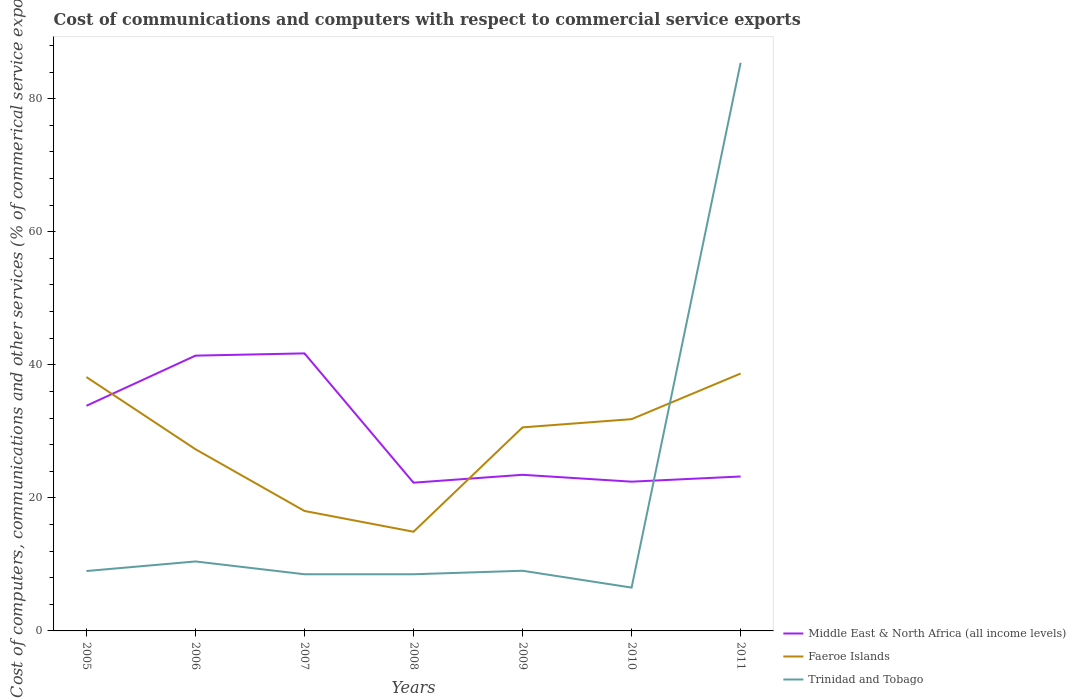How many different coloured lines are there?
Make the answer very short. 3. Does the line corresponding to Middle East & North Africa (all income levels) intersect with the line corresponding to Trinidad and Tobago?
Keep it short and to the point. Yes. Is the number of lines equal to the number of legend labels?
Your answer should be compact. Yes. Across all years, what is the maximum cost of communications and computers in Trinidad and Tobago?
Your answer should be compact. 6.51. What is the total cost of communications and computers in Trinidad and Tobago in the graph?
Your answer should be compact. 0.49. What is the difference between the highest and the second highest cost of communications and computers in Faeroe Islands?
Offer a terse response. 23.78. What is the difference between the highest and the lowest cost of communications and computers in Trinidad and Tobago?
Keep it short and to the point. 1. How many years are there in the graph?
Provide a short and direct response. 7. Are the values on the major ticks of Y-axis written in scientific E-notation?
Provide a succinct answer. No. Does the graph contain grids?
Offer a very short reply. No. How are the legend labels stacked?
Keep it short and to the point. Vertical. What is the title of the graph?
Offer a very short reply. Cost of communications and computers with respect to commercial service exports. What is the label or title of the X-axis?
Ensure brevity in your answer.  Years. What is the label or title of the Y-axis?
Offer a terse response. Cost of computers, communications and other services (% of commerical service exports). What is the Cost of computers, communications and other services (% of commerical service exports) of Middle East & North Africa (all income levels) in 2005?
Offer a terse response. 33.84. What is the Cost of computers, communications and other services (% of commerical service exports) in Faeroe Islands in 2005?
Give a very brief answer. 38.16. What is the Cost of computers, communications and other services (% of commerical service exports) of Trinidad and Tobago in 2005?
Your answer should be very brief. 9. What is the Cost of computers, communications and other services (% of commerical service exports) in Middle East & North Africa (all income levels) in 2006?
Give a very brief answer. 41.38. What is the Cost of computers, communications and other services (% of commerical service exports) of Faeroe Islands in 2006?
Ensure brevity in your answer.  27.32. What is the Cost of computers, communications and other services (% of commerical service exports) of Trinidad and Tobago in 2006?
Offer a terse response. 10.44. What is the Cost of computers, communications and other services (% of commerical service exports) of Middle East & North Africa (all income levels) in 2007?
Ensure brevity in your answer.  41.72. What is the Cost of computers, communications and other services (% of commerical service exports) of Faeroe Islands in 2007?
Your answer should be very brief. 18.03. What is the Cost of computers, communications and other services (% of commerical service exports) in Trinidad and Tobago in 2007?
Provide a succinct answer. 8.52. What is the Cost of computers, communications and other services (% of commerical service exports) of Middle East & North Africa (all income levels) in 2008?
Provide a succinct answer. 22.28. What is the Cost of computers, communications and other services (% of commerical service exports) in Faeroe Islands in 2008?
Your answer should be compact. 14.91. What is the Cost of computers, communications and other services (% of commerical service exports) in Trinidad and Tobago in 2008?
Offer a very short reply. 8.52. What is the Cost of computers, communications and other services (% of commerical service exports) in Middle East & North Africa (all income levels) in 2009?
Provide a short and direct response. 23.47. What is the Cost of computers, communications and other services (% of commerical service exports) of Faeroe Islands in 2009?
Make the answer very short. 30.6. What is the Cost of computers, communications and other services (% of commerical service exports) of Trinidad and Tobago in 2009?
Your response must be concise. 9.05. What is the Cost of computers, communications and other services (% of commerical service exports) of Middle East & North Africa (all income levels) in 2010?
Make the answer very short. 22.44. What is the Cost of computers, communications and other services (% of commerical service exports) in Faeroe Islands in 2010?
Your response must be concise. 31.83. What is the Cost of computers, communications and other services (% of commerical service exports) of Trinidad and Tobago in 2010?
Give a very brief answer. 6.51. What is the Cost of computers, communications and other services (% of commerical service exports) of Middle East & North Africa (all income levels) in 2011?
Your answer should be compact. 23.21. What is the Cost of computers, communications and other services (% of commerical service exports) of Faeroe Islands in 2011?
Ensure brevity in your answer.  38.69. What is the Cost of computers, communications and other services (% of commerical service exports) of Trinidad and Tobago in 2011?
Your answer should be compact. 85.4. Across all years, what is the maximum Cost of computers, communications and other services (% of commerical service exports) in Middle East & North Africa (all income levels)?
Give a very brief answer. 41.72. Across all years, what is the maximum Cost of computers, communications and other services (% of commerical service exports) of Faeroe Islands?
Offer a terse response. 38.69. Across all years, what is the maximum Cost of computers, communications and other services (% of commerical service exports) of Trinidad and Tobago?
Give a very brief answer. 85.4. Across all years, what is the minimum Cost of computers, communications and other services (% of commerical service exports) in Middle East & North Africa (all income levels)?
Offer a terse response. 22.28. Across all years, what is the minimum Cost of computers, communications and other services (% of commerical service exports) of Faeroe Islands?
Offer a very short reply. 14.91. Across all years, what is the minimum Cost of computers, communications and other services (% of commerical service exports) in Trinidad and Tobago?
Your answer should be compact. 6.51. What is the total Cost of computers, communications and other services (% of commerical service exports) of Middle East & North Africa (all income levels) in the graph?
Give a very brief answer. 208.35. What is the total Cost of computers, communications and other services (% of commerical service exports) in Faeroe Islands in the graph?
Make the answer very short. 199.54. What is the total Cost of computers, communications and other services (% of commerical service exports) in Trinidad and Tobago in the graph?
Your answer should be very brief. 137.44. What is the difference between the Cost of computers, communications and other services (% of commerical service exports) in Middle East & North Africa (all income levels) in 2005 and that in 2006?
Ensure brevity in your answer.  -7.54. What is the difference between the Cost of computers, communications and other services (% of commerical service exports) of Faeroe Islands in 2005 and that in 2006?
Your answer should be compact. 10.85. What is the difference between the Cost of computers, communications and other services (% of commerical service exports) of Trinidad and Tobago in 2005 and that in 2006?
Your answer should be compact. -1.44. What is the difference between the Cost of computers, communications and other services (% of commerical service exports) in Middle East & North Africa (all income levels) in 2005 and that in 2007?
Offer a terse response. -7.88. What is the difference between the Cost of computers, communications and other services (% of commerical service exports) of Faeroe Islands in 2005 and that in 2007?
Make the answer very short. 20.13. What is the difference between the Cost of computers, communications and other services (% of commerical service exports) in Trinidad and Tobago in 2005 and that in 2007?
Provide a short and direct response. 0.49. What is the difference between the Cost of computers, communications and other services (% of commerical service exports) in Middle East & North Africa (all income levels) in 2005 and that in 2008?
Keep it short and to the point. 11.56. What is the difference between the Cost of computers, communications and other services (% of commerical service exports) of Faeroe Islands in 2005 and that in 2008?
Make the answer very short. 23.25. What is the difference between the Cost of computers, communications and other services (% of commerical service exports) of Trinidad and Tobago in 2005 and that in 2008?
Keep it short and to the point. 0.49. What is the difference between the Cost of computers, communications and other services (% of commerical service exports) in Middle East & North Africa (all income levels) in 2005 and that in 2009?
Make the answer very short. 10.37. What is the difference between the Cost of computers, communications and other services (% of commerical service exports) in Faeroe Islands in 2005 and that in 2009?
Offer a very short reply. 7.56. What is the difference between the Cost of computers, communications and other services (% of commerical service exports) of Trinidad and Tobago in 2005 and that in 2009?
Keep it short and to the point. -0.04. What is the difference between the Cost of computers, communications and other services (% of commerical service exports) in Middle East & North Africa (all income levels) in 2005 and that in 2010?
Your response must be concise. 11.41. What is the difference between the Cost of computers, communications and other services (% of commerical service exports) in Faeroe Islands in 2005 and that in 2010?
Give a very brief answer. 6.33. What is the difference between the Cost of computers, communications and other services (% of commerical service exports) of Trinidad and Tobago in 2005 and that in 2010?
Your response must be concise. 2.49. What is the difference between the Cost of computers, communications and other services (% of commerical service exports) in Middle East & North Africa (all income levels) in 2005 and that in 2011?
Your response must be concise. 10.63. What is the difference between the Cost of computers, communications and other services (% of commerical service exports) in Faeroe Islands in 2005 and that in 2011?
Your answer should be compact. -0.53. What is the difference between the Cost of computers, communications and other services (% of commerical service exports) of Trinidad and Tobago in 2005 and that in 2011?
Your answer should be very brief. -76.39. What is the difference between the Cost of computers, communications and other services (% of commerical service exports) of Middle East & North Africa (all income levels) in 2006 and that in 2007?
Make the answer very short. -0.34. What is the difference between the Cost of computers, communications and other services (% of commerical service exports) in Faeroe Islands in 2006 and that in 2007?
Make the answer very short. 9.28. What is the difference between the Cost of computers, communications and other services (% of commerical service exports) of Trinidad and Tobago in 2006 and that in 2007?
Keep it short and to the point. 1.93. What is the difference between the Cost of computers, communications and other services (% of commerical service exports) in Middle East & North Africa (all income levels) in 2006 and that in 2008?
Your answer should be very brief. 19.1. What is the difference between the Cost of computers, communications and other services (% of commerical service exports) in Faeroe Islands in 2006 and that in 2008?
Your response must be concise. 12.41. What is the difference between the Cost of computers, communications and other services (% of commerical service exports) in Trinidad and Tobago in 2006 and that in 2008?
Give a very brief answer. 1.93. What is the difference between the Cost of computers, communications and other services (% of commerical service exports) of Middle East & North Africa (all income levels) in 2006 and that in 2009?
Offer a very short reply. 17.91. What is the difference between the Cost of computers, communications and other services (% of commerical service exports) in Faeroe Islands in 2006 and that in 2009?
Offer a terse response. -3.28. What is the difference between the Cost of computers, communications and other services (% of commerical service exports) in Trinidad and Tobago in 2006 and that in 2009?
Offer a terse response. 1.4. What is the difference between the Cost of computers, communications and other services (% of commerical service exports) in Middle East & North Africa (all income levels) in 2006 and that in 2010?
Offer a very short reply. 18.94. What is the difference between the Cost of computers, communications and other services (% of commerical service exports) in Faeroe Islands in 2006 and that in 2010?
Your answer should be very brief. -4.52. What is the difference between the Cost of computers, communications and other services (% of commerical service exports) in Trinidad and Tobago in 2006 and that in 2010?
Your answer should be compact. 3.93. What is the difference between the Cost of computers, communications and other services (% of commerical service exports) in Middle East & North Africa (all income levels) in 2006 and that in 2011?
Make the answer very short. 18.17. What is the difference between the Cost of computers, communications and other services (% of commerical service exports) of Faeroe Islands in 2006 and that in 2011?
Your answer should be very brief. -11.38. What is the difference between the Cost of computers, communications and other services (% of commerical service exports) in Trinidad and Tobago in 2006 and that in 2011?
Provide a succinct answer. -74.96. What is the difference between the Cost of computers, communications and other services (% of commerical service exports) in Middle East & North Africa (all income levels) in 2007 and that in 2008?
Give a very brief answer. 19.44. What is the difference between the Cost of computers, communications and other services (% of commerical service exports) in Faeroe Islands in 2007 and that in 2008?
Keep it short and to the point. 3.12. What is the difference between the Cost of computers, communications and other services (% of commerical service exports) of Trinidad and Tobago in 2007 and that in 2008?
Provide a succinct answer. 0. What is the difference between the Cost of computers, communications and other services (% of commerical service exports) of Middle East & North Africa (all income levels) in 2007 and that in 2009?
Your answer should be compact. 18.25. What is the difference between the Cost of computers, communications and other services (% of commerical service exports) in Faeroe Islands in 2007 and that in 2009?
Ensure brevity in your answer.  -12.57. What is the difference between the Cost of computers, communications and other services (% of commerical service exports) in Trinidad and Tobago in 2007 and that in 2009?
Your answer should be compact. -0.53. What is the difference between the Cost of computers, communications and other services (% of commerical service exports) of Middle East & North Africa (all income levels) in 2007 and that in 2010?
Offer a terse response. 19.28. What is the difference between the Cost of computers, communications and other services (% of commerical service exports) in Faeroe Islands in 2007 and that in 2010?
Ensure brevity in your answer.  -13.8. What is the difference between the Cost of computers, communications and other services (% of commerical service exports) in Trinidad and Tobago in 2007 and that in 2010?
Provide a succinct answer. 2. What is the difference between the Cost of computers, communications and other services (% of commerical service exports) of Middle East & North Africa (all income levels) in 2007 and that in 2011?
Your response must be concise. 18.51. What is the difference between the Cost of computers, communications and other services (% of commerical service exports) in Faeroe Islands in 2007 and that in 2011?
Your answer should be compact. -20.66. What is the difference between the Cost of computers, communications and other services (% of commerical service exports) of Trinidad and Tobago in 2007 and that in 2011?
Provide a succinct answer. -76.88. What is the difference between the Cost of computers, communications and other services (% of commerical service exports) in Middle East & North Africa (all income levels) in 2008 and that in 2009?
Make the answer very short. -1.19. What is the difference between the Cost of computers, communications and other services (% of commerical service exports) of Faeroe Islands in 2008 and that in 2009?
Give a very brief answer. -15.69. What is the difference between the Cost of computers, communications and other services (% of commerical service exports) of Trinidad and Tobago in 2008 and that in 2009?
Your answer should be very brief. -0.53. What is the difference between the Cost of computers, communications and other services (% of commerical service exports) in Middle East & North Africa (all income levels) in 2008 and that in 2010?
Keep it short and to the point. -0.15. What is the difference between the Cost of computers, communications and other services (% of commerical service exports) in Faeroe Islands in 2008 and that in 2010?
Provide a short and direct response. -16.92. What is the difference between the Cost of computers, communications and other services (% of commerical service exports) of Trinidad and Tobago in 2008 and that in 2010?
Offer a terse response. 2. What is the difference between the Cost of computers, communications and other services (% of commerical service exports) of Middle East & North Africa (all income levels) in 2008 and that in 2011?
Make the answer very short. -0.93. What is the difference between the Cost of computers, communications and other services (% of commerical service exports) of Faeroe Islands in 2008 and that in 2011?
Provide a succinct answer. -23.78. What is the difference between the Cost of computers, communications and other services (% of commerical service exports) in Trinidad and Tobago in 2008 and that in 2011?
Ensure brevity in your answer.  -76.88. What is the difference between the Cost of computers, communications and other services (% of commerical service exports) in Faeroe Islands in 2009 and that in 2010?
Offer a terse response. -1.24. What is the difference between the Cost of computers, communications and other services (% of commerical service exports) of Trinidad and Tobago in 2009 and that in 2010?
Give a very brief answer. 2.53. What is the difference between the Cost of computers, communications and other services (% of commerical service exports) in Middle East & North Africa (all income levels) in 2009 and that in 2011?
Make the answer very short. 0.25. What is the difference between the Cost of computers, communications and other services (% of commerical service exports) in Faeroe Islands in 2009 and that in 2011?
Your response must be concise. -8.1. What is the difference between the Cost of computers, communications and other services (% of commerical service exports) of Trinidad and Tobago in 2009 and that in 2011?
Offer a very short reply. -76.35. What is the difference between the Cost of computers, communications and other services (% of commerical service exports) in Middle East & North Africa (all income levels) in 2010 and that in 2011?
Your response must be concise. -0.78. What is the difference between the Cost of computers, communications and other services (% of commerical service exports) of Faeroe Islands in 2010 and that in 2011?
Offer a very short reply. -6.86. What is the difference between the Cost of computers, communications and other services (% of commerical service exports) of Trinidad and Tobago in 2010 and that in 2011?
Your answer should be compact. -78.88. What is the difference between the Cost of computers, communications and other services (% of commerical service exports) in Middle East & North Africa (all income levels) in 2005 and the Cost of computers, communications and other services (% of commerical service exports) in Faeroe Islands in 2006?
Offer a very short reply. 6.53. What is the difference between the Cost of computers, communications and other services (% of commerical service exports) of Middle East & North Africa (all income levels) in 2005 and the Cost of computers, communications and other services (% of commerical service exports) of Trinidad and Tobago in 2006?
Your answer should be compact. 23.4. What is the difference between the Cost of computers, communications and other services (% of commerical service exports) in Faeroe Islands in 2005 and the Cost of computers, communications and other services (% of commerical service exports) in Trinidad and Tobago in 2006?
Provide a short and direct response. 27.72. What is the difference between the Cost of computers, communications and other services (% of commerical service exports) in Middle East & North Africa (all income levels) in 2005 and the Cost of computers, communications and other services (% of commerical service exports) in Faeroe Islands in 2007?
Your answer should be very brief. 15.81. What is the difference between the Cost of computers, communications and other services (% of commerical service exports) of Middle East & North Africa (all income levels) in 2005 and the Cost of computers, communications and other services (% of commerical service exports) of Trinidad and Tobago in 2007?
Offer a very short reply. 25.33. What is the difference between the Cost of computers, communications and other services (% of commerical service exports) in Faeroe Islands in 2005 and the Cost of computers, communications and other services (% of commerical service exports) in Trinidad and Tobago in 2007?
Provide a short and direct response. 29.64. What is the difference between the Cost of computers, communications and other services (% of commerical service exports) of Middle East & North Africa (all income levels) in 2005 and the Cost of computers, communications and other services (% of commerical service exports) of Faeroe Islands in 2008?
Give a very brief answer. 18.93. What is the difference between the Cost of computers, communications and other services (% of commerical service exports) of Middle East & North Africa (all income levels) in 2005 and the Cost of computers, communications and other services (% of commerical service exports) of Trinidad and Tobago in 2008?
Offer a very short reply. 25.33. What is the difference between the Cost of computers, communications and other services (% of commerical service exports) in Faeroe Islands in 2005 and the Cost of computers, communications and other services (% of commerical service exports) in Trinidad and Tobago in 2008?
Your answer should be compact. 29.65. What is the difference between the Cost of computers, communications and other services (% of commerical service exports) of Middle East & North Africa (all income levels) in 2005 and the Cost of computers, communications and other services (% of commerical service exports) of Faeroe Islands in 2009?
Provide a short and direct response. 3.25. What is the difference between the Cost of computers, communications and other services (% of commerical service exports) of Middle East & North Africa (all income levels) in 2005 and the Cost of computers, communications and other services (% of commerical service exports) of Trinidad and Tobago in 2009?
Provide a short and direct response. 24.8. What is the difference between the Cost of computers, communications and other services (% of commerical service exports) in Faeroe Islands in 2005 and the Cost of computers, communications and other services (% of commerical service exports) in Trinidad and Tobago in 2009?
Keep it short and to the point. 29.12. What is the difference between the Cost of computers, communications and other services (% of commerical service exports) in Middle East & North Africa (all income levels) in 2005 and the Cost of computers, communications and other services (% of commerical service exports) in Faeroe Islands in 2010?
Your answer should be very brief. 2.01. What is the difference between the Cost of computers, communications and other services (% of commerical service exports) in Middle East & North Africa (all income levels) in 2005 and the Cost of computers, communications and other services (% of commerical service exports) in Trinidad and Tobago in 2010?
Your response must be concise. 27.33. What is the difference between the Cost of computers, communications and other services (% of commerical service exports) in Faeroe Islands in 2005 and the Cost of computers, communications and other services (% of commerical service exports) in Trinidad and Tobago in 2010?
Offer a terse response. 31.65. What is the difference between the Cost of computers, communications and other services (% of commerical service exports) of Middle East & North Africa (all income levels) in 2005 and the Cost of computers, communications and other services (% of commerical service exports) of Faeroe Islands in 2011?
Your answer should be compact. -4.85. What is the difference between the Cost of computers, communications and other services (% of commerical service exports) of Middle East & North Africa (all income levels) in 2005 and the Cost of computers, communications and other services (% of commerical service exports) of Trinidad and Tobago in 2011?
Make the answer very short. -51.55. What is the difference between the Cost of computers, communications and other services (% of commerical service exports) in Faeroe Islands in 2005 and the Cost of computers, communications and other services (% of commerical service exports) in Trinidad and Tobago in 2011?
Ensure brevity in your answer.  -47.24. What is the difference between the Cost of computers, communications and other services (% of commerical service exports) of Middle East & North Africa (all income levels) in 2006 and the Cost of computers, communications and other services (% of commerical service exports) of Faeroe Islands in 2007?
Provide a succinct answer. 23.35. What is the difference between the Cost of computers, communications and other services (% of commerical service exports) in Middle East & North Africa (all income levels) in 2006 and the Cost of computers, communications and other services (% of commerical service exports) in Trinidad and Tobago in 2007?
Ensure brevity in your answer.  32.86. What is the difference between the Cost of computers, communications and other services (% of commerical service exports) in Faeroe Islands in 2006 and the Cost of computers, communications and other services (% of commerical service exports) in Trinidad and Tobago in 2007?
Make the answer very short. 18.8. What is the difference between the Cost of computers, communications and other services (% of commerical service exports) in Middle East & North Africa (all income levels) in 2006 and the Cost of computers, communications and other services (% of commerical service exports) in Faeroe Islands in 2008?
Provide a succinct answer. 26.47. What is the difference between the Cost of computers, communications and other services (% of commerical service exports) of Middle East & North Africa (all income levels) in 2006 and the Cost of computers, communications and other services (% of commerical service exports) of Trinidad and Tobago in 2008?
Your response must be concise. 32.87. What is the difference between the Cost of computers, communications and other services (% of commerical service exports) in Faeroe Islands in 2006 and the Cost of computers, communications and other services (% of commerical service exports) in Trinidad and Tobago in 2008?
Your response must be concise. 18.8. What is the difference between the Cost of computers, communications and other services (% of commerical service exports) in Middle East & North Africa (all income levels) in 2006 and the Cost of computers, communications and other services (% of commerical service exports) in Faeroe Islands in 2009?
Give a very brief answer. 10.78. What is the difference between the Cost of computers, communications and other services (% of commerical service exports) of Middle East & North Africa (all income levels) in 2006 and the Cost of computers, communications and other services (% of commerical service exports) of Trinidad and Tobago in 2009?
Give a very brief answer. 32.34. What is the difference between the Cost of computers, communications and other services (% of commerical service exports) of Faeroe Islands in 2006 and the Cost of computers, communications and other services (% of commerical service exports) of Trinidad and Tobago in 2009?
Make the answer very short. 18.27. What is the difference between the Cost of computers, communications and other services (% of commerical service exports) of Middle East & North Africa (all income levels) in 2006 and the Cost of computers, communications and other services (% of commerical service exports) of Faeroe Islands in 2010?
Your response must be concise. 9.55. What is the difference between the Cost of computers, communications and other services (% of commerical service exports) of Middle East & North Africa (all income levels) in 2006 and the Cost of computers, communications and other services (% of commerical service exports) of Trinidad and Tobago in 2010?
Offer a terse response. 34.87. What is the difference between the Cost of computers, communications and other services (% of commerical service exports) of Faeroe Islands in 2006 and the Cost of computers, communications and other services (% of commerical service exports) of Trinidad and Tobago in 2010?
Offer a terse response. 20.8. What is the difference between the Cost of computers, communications and other services (% of commerical service exports) of Middle East & North Africa (all income levels) in 2006 and the Cost of computers, communications and other services (% of commerical service exports) of Faeroe Islands in 2011?
Your answer should be very brief. 2.69. What is the difference between the Cost of computers, communications and other services (% of commerical service exports) of Middle East & North Africa (all income levels) in 2006 and the Cost of computers, communications and other services (% of commerical service exports) of Trinidad and Tobago in 2011?
Keep it short and to the point. -44.02. What is the difference between the Cost of computers, communications and other services (% of commerical service exports) of Faeroe Islands in 2006 and the Cost of computers, communications and other services (% of commerical service exports) of Trinidad and Tobago in 2011?
Your answer should be compact. -58.08. What is the difference between the Cost of computers, communications and other services (% of commerical service exports) in Middle East & North Africa (all income levels) in 2007 and the Cost of computers, communications and other services (% of commerical service exports) in Faeroe Islands in 2008?
Offer a terse response. 26.81. What is the difference between the Cost of computers, communications and other services (% of commerical service exports) in Middle East & North Africa (all income levels) in 2007 and the Cost of computers, communications and other services (% of commerical service exports) in Trinidad and Tobago in 2008?
Make the answer very short. 33.2. What is the difference between the Cost of computers, communications and other services (% of commerical service exports) of Faeroe Islands in 2007 and the Cost of computers, communications and other services (% of commerical service exports) of Trinidad and Tobago in 2008?
Your response must be concise. 9.51. What is the difference between the Cost of computers, communications and other services (% of commerical service exports) of Middle East & North Africa (all income levels) in 2007 and the Cost of computers, communications and other services (% of commerical service exports) of Faeroe Islands in 2009?
Provide a succinct answer. 11.12. What is the difference between the Cost of computers, communications and other services (% of commerical service exports) of Middle East & North Africa (all income levels) in 2007 and the Cost of computers, communications and other services (% of commerical service exports) of Trinidad and Tobago in 2009?
Your response must be concise. 32.67. What is the difference between the Cost of computers, communications and other services (% of commerical service exports) of Faeroe Islands in 2007 and the Cost of computers, communications and other services (% of commerical service exports) of Trinidad and Tobago in 2009?
Offer a terse response. 8.99. What is the difference between the Cost of computers, communications and other services (% of commerical service exports) in Middle East & North Africa (all income levels) in 2007 and the Cost of computers, communications and other services (% of commerical service exports) in Faeroe Islands in 2010?
Provide a succinct answer. 9.89. What is the difference between the Cost of computers, communications and other services (% of commerical service exports) of Middle East & North Africa (all income levels) in 2007 and the Cost of computers, communications and other services (% of commerical service exports) of Trinidad and Tobago in 2010?
Make the answer very short. 35.21. What is the difference between the Cost of computers, communications and other services (% of commerical service exports) in Faeroe Islands in 2007 and the Cost of computers, communications and other services (% of commerical service exports) in Trinidad and Tobago in 2010?
Provide a succinct answer. 11.52. What is the difference between the Cost of computers, communications and other services (% of commerical service exports) in Middle East & North Africa (all income levels) in 2007 and the Cost of computers, communications and other services (% of commerical service exports) in Faeroe Islands in 2011?
Offer a very short reply. 3.03. What is the difference between the Cost of computers, communications and other services (% of commerical service exports) of Middle East & North Africa (all income levels) in 2007 and the Cost of computers, communications and other services (% of commerical service exports) of Trinidad and Tobago in 2011?
Your response must be concise. -43.68. What is the difference between the Cost of computers, communications and other services (% of commerical service exports) in Faeroe Islands in 2007 and the Cost of computers, communications and other services (% of commerical service exports) in Trinidad and Tobago in 2011?
Provide a short and direct response. -67.37. What is the difference between the Cost of computers, communications and other services (% of commerical service exports) of Middle East & North Africa (all income levels) in 2008 and the Cost of computers, communications and other services (% of commerical service exports) of Faeroe Islands in 2009?
Ensure brevity in your answer.  -8.31. What is the difference between the Cost of computers, communications and other services (% of commerical service exports) of Middle East & North Africa (all income levels) in 2008 and the Cost of computers, communications and other services (% of commerical service exports) of Trinidad and Tobago in 2009?
Make the answer very short. 13.24. What is the difference between the Cost of computers, communications and other services (% of commerical service exports) of Faeroe Islands in 2008 and the Cost of computers, communications and other services (% of commerical service exports) of Trinidad and Tobago in 2009?
Provide a succinct answer. 5.86. What is the difference between the Cost of computers, communications and other services (% of commerical service exports) of Middle East & North Africa (all income levels) in 2008 and the Cost of computers, communications and other services (% of commerical service exports) of Faeroe Islands in 2010?
Keep it short and to the point. -9.55. What is the difference between the Cost of computers, communications and other services (% of commerical service exports) in Middle East & North Africa (all income levels) in 2008 and the Cost of computers, communications and other services (% of commerical service exports) in Trinidad and Tobago in 2010?
Give a very brief answer. 15.77. What is the difference between the Cost of computers, communications and other services (% of commerical service exports) of Faeroe Islands in 2008 and the Cost of computers, communications and other services (% of commerical service exports) of Trinidad and Tobago in 2010?
Provide a short and direct response. 8.4. What is the difference between the Cost of computers, communications and other services (% of commerical service exports) in Middle East & North Africa (all income levels) in 2008 and the Cost of computers, communications and other services (% of commerical service exports) in Faeroe Islands in 2011?
Provide a succinct answer. -16.41. What is the difference between the Cost of computers, communications and other services (% of commerical service exports) in Middle East & North Africa (all income levels) in 2008 and the Cost of computers, communications and other services (% of commerical service exports) in Trinidad and Tobago in 2011?
Ensure brevity in your answer.  -63.12. What is the difference between the Cost of computers, communications and other services (% of commerical service exports) of Faeroe Islands in 2008 and the Cost of computers, communications and other services (% of commerical service exports) of Trinidad and Tobago in 2011?
Keep it short and to the point. -70.49. What is the difference between the Cost of computers, communications and other services (% of commerical service exports) of Middle East & North Africa (all income levels) in 2009 and the Cost of computers, communications and other services (% of commerical service exports) of Faeroe Islands in 2010?
Ensure brevity in your answer.  -8.36. What is the difference between the Cost of computers, communications and other services (% of commerical service exports) in Middle East & North Africa (all income levels) in 2009 and the Cost of computers, communications and other services (% of commerical service exports) in Trinidad and Tobago in 2010?
Give a very brief answer. 16.95. What is the difference between the Cost of computers, communications and other services (% of commerical service exports) of Faeroe Islands in 2009 and the Cost of computers, communications and other services (% of commerical service exports) of Trinidad and Tobago in 2010?
Your response must be concise. 24.08. What is the difference between the Cost of computers, communications and other services (% of commerical service exports) of Middle East & North Africa (all income levels) in 2009 and the Cost of computers, communications and other services (% of commerical service exports) of Faeroe Islands in 2011?
Your answer should be compact. -15.22. What is the difference between the Cost of computers, communications and other services (% of commerical service exports) in Middle East & North Africa (all income levels) in 2009 and the Cost of computers, communications and other services (% of commerical service exports) in Trinidad and Tobago in 2011?
Offer a very short reply. -61.93. What is the difference between the Cost of computers, communications and other services (% of commerical service exports) in Faeroe Islands in 2009 and the Cost of computers, communications and other services (% of commerical service exports) in Trinidad and Tobago in 2011?
Make the answer very short. -54.8. What is the difference between the Cost of computers, communications and other services (% of commerical service exports) of Middle East & North Africa (all income levels) in 2010 and the Cost of computers, communications and other services (% of commerical service exports) of Faeroe Islands in 2011?
Provide a succinct answer. -16.26. What is the difference between the Cost of computers, communications and other services (% of commerical service exports) in Middle East & North Africa (all income levels) in 2010 and the Cost of computers, communications and other services (% of commerical service exports) in Trinidad and Tobago in 2011?
Offer a terse response. -62.96. What is the difference between the Cost of computers, communications and other services (% of commerical service exports) of Faeroe Islands in 2010 and the Cost of computers, communications and other services (% of commerical service exports) of Trinidad and Tobago in 2011?
Your answer should be compact. -53.57. What is the average Cost of computers, communications and other services (% of commerical service exports) in Middle East & North Africa (all income levels) per year?
Provide a short and direct response. 29.76. What is the average Cost of computers, communications and other services (% of commerical service exports) of Faeroe Islands per year?
Give a very brief answer. 28.51. What is the average Cost of computers, communications and other services (% of commerical service exports) of Trinidad and Tobago per year?
Keep it short and to the point. 19.63. In the year 2005, what is the difference between the Cost of computers, communications and other services (% of commerical service exports) of Middle East & North Africa (all income levels) and Cost of computers, communications and other services (% of commerical service exports) of Faeroe Islands?
Keep it short and to the point. -4.32. In the year 2005, what is the difference between the Cost of computers, communications and other services (% of commerical service exports) in Middle East & North Africa (all income levels) and Cost of computers, communications and other services (% of commerical service exports) in Trinidad and Tobago?
Make the answer very short. 24.84. In the year 2005, what is the difference between the Cost of computers, communications and other services (% of commerical service exports) in Faeroe Islands and Cost of computers, communications and other services (% of commerical service exports) in Trinidad and Tobago?
Ensure brevity in your answer.  29.16. In the year 2006, what is the difference between the Cost of computers, communications and other services (% of commerical service exports) of Middle East & North Africa (all income levels) and Cost of computers, communications and other services (% of commerical service exports) of Faeroe Islands?
Your answer should be very brief. 14.07. In the year 2006, what is the difference between the Cost of computers, communications and other services (% of commerical service exports) of Middle East & North Africa (all income levels) and Cost of computers, communications and other services (% of commerical service exports) of Trinidad and Tobago?
Your answer should be very brief. 30.94. In the year 2006, what is the difference between the Cost of computers, communications and other services (% of commerical service exports) of Faeroe Islands and Cost of computers, communications and other services (% of commerical service exports) of Trinidad and Tobago?
Provide a short and direct response. 16.87. In the year 2007, what is the difference between the Cost of computers, communications and other services (% of commerical service exports) in Middle East & North Africa (all income levels) and Cost of computers, communications and other services (% of commerical service exports) in Faeroe Islands?
Your answer should be very brief. 23.69. In the year 2007, what is the difference between the Cost of computers, communications and other services (% of commerical service exports) of Middle East & North Africa (all income levels) and Cost of computers, communications and other services (% of commerical service exports) of Trinidad and Tobago?
Give a very brief answer. 33.2. In the year 2007, what is the difference between the Cost of computers, communications and other services (% of commerical service exports) in Faeroe Islands and Cost of computers, communications and other services (% of commerical service exports) in Trinidad and Tobago?
Provide a short and direct response. 9.51. In the year 2008, what is the difference between the Cost of computers, communications and other services (% of commerical service exports) of Middle East & North Africa (all income levels) and Cost of computers, communications and other services (% of commerical service exports) of Faeroe Islands?
Offer a very short reply. 7.37. In the year 2008, what is the difference between the Cost of computers, communications and other services (% of commerical service exports) of Middle East & North Africa (all income levels) and Cost of computers, communications and other services (% of commerical service exports) of Trinidad and Tobago?
Provide a short and direct response. 13.77. In the year 2008, what is the difference between the Cost of computers, communications and other services (% of commerical service exports) of Faeroe Islands and Cost of computers, communications and other services (% of commerical service exports) of Trinidad and Tobago?
Provide a short and direct response. 6.39. In the year 2009, what is the difference between the Cost of computers, communications and other services (% of commerical service exports) in Middle East & North Africa (all income levels) and Cost of computers, communications and other services (% of commerical service exports) in Faeroe Islands?
Your answer should be compact. -7.13. In the year 2009, what is the difference between the Cost of computers, communications and other services (% of commerical service exports) of Middle East & North Africa (all income levels) and Cost of computers, communications and other services (% of commerical service exports) of Trinidad and Tobago?
Provide a succinct answer. 14.42. In the year 2009, what is the difference between the Cost of computers, communications and other services (% of commerical service exports) in Faeroe Islands and Cost of computers, communications and other services (% of commerical service exports) in Trinidad and Tobago?
Offer a terse response. 21.55. In the year 2010, what is the difference between the Cost of computers, communications and other services (% of commerical service exports) in Middle East & North Africa (all income levels) and Cost of computers, communications and other services (% of commerical service exports) in Faeroe Islands?
Offer a terse response. -9.4. In the year 2010, what is the difference between the Cost of computers, communications and other services (% of commerical service exports) of Middle East & North Africa (all income levels) and Cost of computers, communications and other services (% of commerical service exports) of Trinidad and Tobago?
Your answer should be very brief. 15.92. In the year 2010, what is the difference between the Cost of computers, communications and other services (% of commerical service exports) of Faeroe Islands and Cost of computers, communications and other services (% of commerical service exports) of Trinidad and Tobago?
Your answer should be compact. 25.32. In the year 2011, what is the difference between the Cost of computers, communications and other services (% of commerical service exports) in Middle East & North Africa (all income levels) and Cost of computers, communications and other services (% of commerical service exports) in Faeroe Islands?
Your answer should be very brief. -15.48. In the year 2011, what is the difference between the Cost of computers, communications and other services (% of commerical service exports) in Middle East & North Africa (all income levels) and Cost of computers, communications and other services (% of commerical service exports) in Trinidad and Tobago?
Your response must be concise. -62.18. In the year 2011, what is the difference between the Cost of computers, communications and other services (% of commerical service exports) of Faeroe Islands and Cost of computers, communications and other services (% of commerical service exports) of Trinidad and Tobago?
Provide a short and direct response. -46.71. What is the ratio of the Cost of computers, communications and other services (% of commerical service exports) in Middle East & North Africa (all income levels) in 2005 to that in 2006?
Ensure brevity in your answer.  0.82. What is the ratio of the Cost of computers, communications and other services (% of commerical service exports) in Faeroe Islands in 2005 to that in 2006?
Provide a succinct answer. 1.4. What is the ratio of the Cost of computers, communications and other services (% of commerical service exports) of Trinidad and Tobago in 2005 to that in 2006?
Your answer should be very brief. 0.86. What is the ratio of the Cost of computers, communications and other services (% of commerical service exports) in Middle East & North Africa (all income levels) in 2005 to that in 2007?
Give a very brief answer. 0.81. What is the ratio of the Cost of computers, communications and other services (% of commerical service exports) of Faeroe Islands in 2005 to that in 2007?
Provide a succinct answer. 2.12. What is the ratio of the Cost of computers, communications and other services (% of commerical service exports) in Trinidad and Tobago in 2005 to that in 2007?
Keep it short and to the point. 1.06. What is the ratio of the Cost of computers, communications and other services (% of commerical service exports) in Middle East & North Africa (all income levels) in 2005 to that in 2008?
Your answer should be compact. 1.52. What is the ratio of the Cost of computers, communications and other services (% of commerical service exports) of Faeroe Islands in 2005 to that in 2008?
Give a very brief answer. 2.56. What is the ratio of the Cost of computers, communications and other services (% of commerical service exports) in Trinidad and Tobago in 2005 to that in 2008?
Make the answer very short. 1.06. What is the ratio of the Cost of computers, communications and other services (% of commerical service exports) in Middle East & North Africa (all income levels) in 2005 to that in 2009?
Make the answer very short. 1.44. What is the ratio of the Cost of computers, communications and other services (% of commerical service exports) of Faeroe Islands in 2005 to that in 2009?
Your answer should be compact. 1.25. What is the ratio of the Cost of computers, communications and other services (% of commerical service exports) in Middle East & North Africa (all income levels) in 2005 to that in 2010?
Your answer should be very brief. 1.51. What is the ratio of the Cost of computers, communications and other services (% of commerical service exports) of Faeroe Islands in 2005 to that in 2010?
Your answer should be compact. 1.2. What is the ratio of the Cost of computers, communications and other services (% of commerical service exports) of Trinidad and Tobago in 2005 to that in 2010?
Give a very brief answer. 1.38. What is the ratio of the Cost of computers, communications and other services (% of commerical service exports) of Middle East & North Africa (all income levels) in 2005 to that in 2011?
Keep it short and to the point. 1.46. What is the ratio of the Cost of computers, communications and other services (% of commerical service exports) in Faeroe Islands in 2005 to that in 2011?
Your response must be concise. 0.99. What is the ratio of the Cost of computers, communications and other services (% of commerical service exports) in Trinidad and Tobago in 2005 to that in 2011?
Your answer should be compact. 0.11. What is the ratio of the Cost of computers, communications and other services (% of commerical service exports) in Faeroe Islands in 2006 to that in 2007?
Your answer should be compact. 1.51. What is the ratio of the Cost of computers, communications and other services (% of commerical service exports) of Trinidad and Tobago in 2006 to that in 2007?
Provide a succinct answer. 1.23. What is the ratio of the Cost of computers, communications and other services (% of commerical service exports) of Middle East & North Africa (all income levels) in 2006 to that in 2008?
Your response must be concise. 1.86. What is the ratio of the Cost of computers, communications and other services (% of commerical service exports) of Faeroe Islands in 2006 to that in 2008?
Offer a terse response. 1.83. What is the ratio of the Cost of computers, communications and other services (% of commerical service exports) of Trinidad and Tobago in 2006 to that in 2008?
Provide a short and direct response. 1.23. What is the ratio of the Cost of computers, communications and other services (% of commerical service exports) in Middle East & North Africa (all income levels) in 2006 to that in 2009?
Your answer should be very brief. 1.76. What is the ratio of the Cost of computers, communications and other services (% of commerical service exports) in Faeroe Islands in 2006 to that in 2009?
Offer a very short reply. 0.89. What is the ratio of the Cost of computers, communications and other services (% of commerical service exports) of Trinidad and Tobago in 2006 to that in 2009?
Ensure brevity in your answer.  1.15. What is the ratio of the Cost of computers, communications and other services (% of commerical service exports) of Middle East & North Africa (all income levels) in 2006 to that in 2010?
Offer a very short reply. 1.84. What is the ratio of the Cost of computers, communications and other services (% of commerical service exports) in Faeroe Islands in 2006 to that in 2010?
Give a very brief answer. 0.86. What is the ratio of the Cost of computers, communications and other services (% of commerical service exports) of Trinidad and Tobago in 2006 to that in 2010?
Ensure brevity in your answer.  1.6. What is the ratio of the Cost of computers, communications and other services (% of commerical service exports) of Middle East & North Africa (all income levels) in 2006 to that in 2011?
Your response must be concise. 1.78. What is the ratio of the Cost of computers, communications and other services (% of commerical service exports) in Faeroe Islands in 2006 to that in 2011?
Make the answer very short. 0.71. What is the ratio of the Cost of computers, communications and other services (% of commerical service exports) of Trinidad and Tobago in 2006 to that in 2011?
Give a very brief answer. 0.12. What is the ratio of the Cost of computers, communications and other services (% of commerical service exports) in Middle East & North Africa (all income levels) in 2007 to that in 2008?
Provide a short and direct response. 1.87. What is the ratio of the Cost of computers, communications and other services (% of commerical service exports) in Faeroe Islands in 2007 to that in 2008?
Provide a short and direct response. 1.21. What is the ratio of the Cost of computers, communications and other services (% of commerical service exports) in Middle East & North Africa (all income levels) in 2007 to that in 2009?
Your response must be concise. 1.78. What is the ratio of the Cost of computers, communications and other services (% of commerical service exports) in Faeroe Islands in 2007 to that in 2009?
Provide a succinct answer. 0.59. What is the ratio of the Cost of computers, communications and other services (% of commerical service exports) in Trinidad and Tobago in 2007 to that in 2009?
Your answer should be very brief. 0.94. What is the ratio of the Cost of computers, communications and other services (% of commerical service exports) of Middle East & North Africa (all income levels) in 2007 to that in 2010?
Offer a very short reply. 1.86. What is the ratio of the Cost of computers, communications and other services (% of commerical service exports) in Faeroe Islands in 2007 to that in 2010?
Offer a very short reply. 0.57. What is the ratio of the Cost of computers, communications and other services (% of commerical service exports) in Trinidad and Tobago in 2007 to that in 2010?
Provide a short and direct response. 1.31. What is the ratio of the Cost of computers, communications and other services (% of commerical service exports) in Middle East & North Africa (all income levels) in 2007 to that in 2011?
Your answer should be very brief. 1.8. What is the ratio of the Cost of computers, communications and other services (% of commerical service exports) of Faeroe Islands in 2007 to that in 2011?
Provide a succinct answer. 0.47. What is the ratio of the Cost of computers, communications and other services (% of commerical service exports) in Trinidad and Tobago in 2007 to that in 2011?
Make the answer very short. 0.1. What is the ratio of the Cost of computers, communications and other services (% of commerical service exports) of Middle East & North Africa (all income levels) in 2008 to that in 2009?
Keep it short and to the point. 0.95. What is the ratio of the Cost of computers, communications and other services (% of commerical service exports) in Faeroe Islands in 2008 to that in 2009?
Provide a succinct answer. 0.49. What is the ratio of the Cost of computers, communications and other services (% of commerical service exports) of Trinidad and Tobago in 2008 to that in 2009?
Give a very brief answer. 0.94. What is the ratio of the Cost of computers, communications and other services (% of commerical service exports) of Middle East & North Africa (all income levels) in 2008 to that in 2010?
Make the answer very short. 0.99. What is the ratio of the Cost of computers, communications and other services (% of commerical service exports) in Faeroe Islands in 2008 to that in 2010?
Keep it short and to the point. 0.47. What is the ratio of the Cost of computers, communications and other services (% of commerical service exports) in Trinidad and Tobago in 2008 to that in 2010?
Offer a terse response. 1.31. What is the ratio of the Cost of computers, communications and other services (% of commerical service exports) in Middle East & North Africa (all income levels) in 2008 to that in 2011?
Your response must be concise. 0.96. What is the ratio of the Cost of computers, communications and other services (% of commerical service exports) in Faeroe Islands in 2008 to that in 2011?
Give a very brief answer. 0.39. What is the ratio of the Cost of computers, communications and other services (% of commerical service exports) in Trinidad and Tobago in 2008 to that in 2011?
Ensure brevity in your answer.  0.1. What is the ratio of the Cost of computers, communications and other services (% of commerical service exports) in Middle East & North Africa (all income levels) in 2009 to that in 2010?
Your answer should be very brief. 1.05. What is the ratio of the Cost of computers, communications and other services (% of commerical service exports) of Faeroe Islands in 2009 to that in 2010?
Ensure brevity in your answer.  0.96. What is the ratio of the Cost of computers, communications and other services (% of commerical service exports) of Trinidad and Tobago in 2009 to that in 2010?
Offer a very short reply. 1.39. What is the ratio of the Cost of computers, communications and other services (% of commerical service exports) of Faeroe Islands in 2009 to that in 2011?
Give a very brief answer. 0.79. What is the ratio of the Cost of computers, communications and other services (% of commerical service exports) in Trinidad and Tobago in 2009 to that in 2011?
Offer a very short reply. 0.11. What is the ratio of the Cost of computers, communications and other services (% of commerical service exports) of Middle East & North Africa (all income levels) in 2010 to that in 2011?
Provide a short and direct response. 0.97. What is the ratio of the Cost of computers, communications and other services (% of commerical service exports) in Faeroe Islands in 2010 to that in 2011?
Your answer should be very brief. 0.82. What is the ratio of the Cost of computers, communications and other services (% of commerical service exports) in Trinidad and Tobago in 2010 to that in 2011?
Make the answer very short. 0.08. What is the difference between the highest and the second highest Cost of computers, communications and other services (% of commerical service exports) in Middle East & North Africa (all income levels)?
Make the answer very short. 0.34. What is the difference between the highest and the second highest Cost of computers, communications and other services (% of commerical service exports) in Faeroe Islands?
Ensure brevity in your answer.  0.53. What is the difference between the highest and the second highest Cost of computers, communications and other services (% of commerical service exports) of Trinidad and Tobago?
Keep it short and to the point. 74.96. What is the difference between the highest and the lowest Cost of computers, communications and other services (% of commerical service exports) of Middle East & North Africa (all income levels)?
Offer a very short reply. 19.44. What is the difference between the highest and the lowest Cost of computers, communications and other services (% of commerical service exports) in Faeroe Islands?
Keep it short and to the point. 23.78. What is the difference between the highest and the lowest Cost of computers, communications and other services (% of commerical service exports) of Trinidad and Tobago?
Your answer should be very brief. 78.88. 